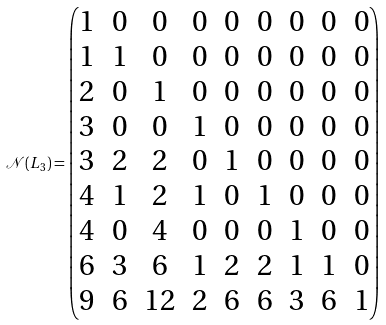<formula> <loc_0><loc_0><loc_500><loc_500>\mathcal { N } ( L _ { 3 } ) = \begin{pmatrix} 1 & 0 & 0 & 0 & 0 & 0 & 0 & 0 & 0 \\ 1 & 1 & 0 & 0 & 0 & 0 & 0 & 0 & 0 \\ 2 & 0 & 1 & 0 & 0 & 0 & 0 & 0 & 0 \\ 3 & 0 & 0 & 1 & 0 & 0 & 0 & 0 & 0 \\ 3 & 2 & 2 & 0 & 1 & 0 & 0 & 0 & 0 \\ 4 & 1 & 2 & 1 & 0 & 1 & 0 & 0 & 0 \\ 4 & 0 & 4 & 0 & 0 & 0 & 1 & 0 & 0 \\ 6 & 3 & 6 & 1 & 2 & 2 & 1 & 1 & 0 \\ 9 & 6 & 1 2 & 2 & 6 & 6 & 3 & 6 & 1 \\ \end{pmatrix}</formula> 